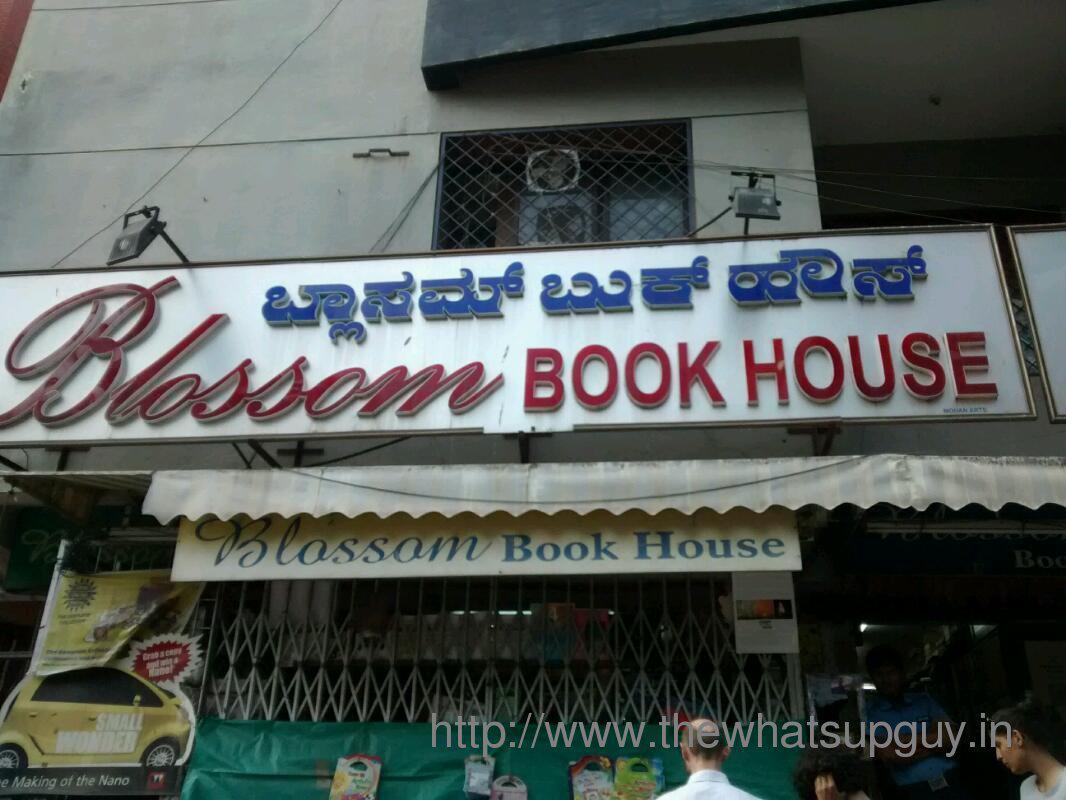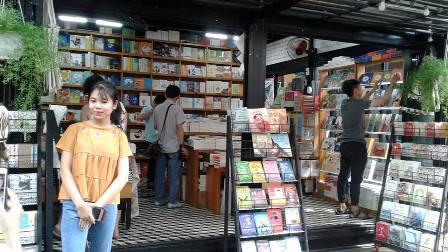The first image is the image on the left, the second image is the image on the right. Considering the images on both sides, is "Left images shows a shop with a lattice-like structure in front, behind a banner sign." valid? Answer yes or no. Yes. 